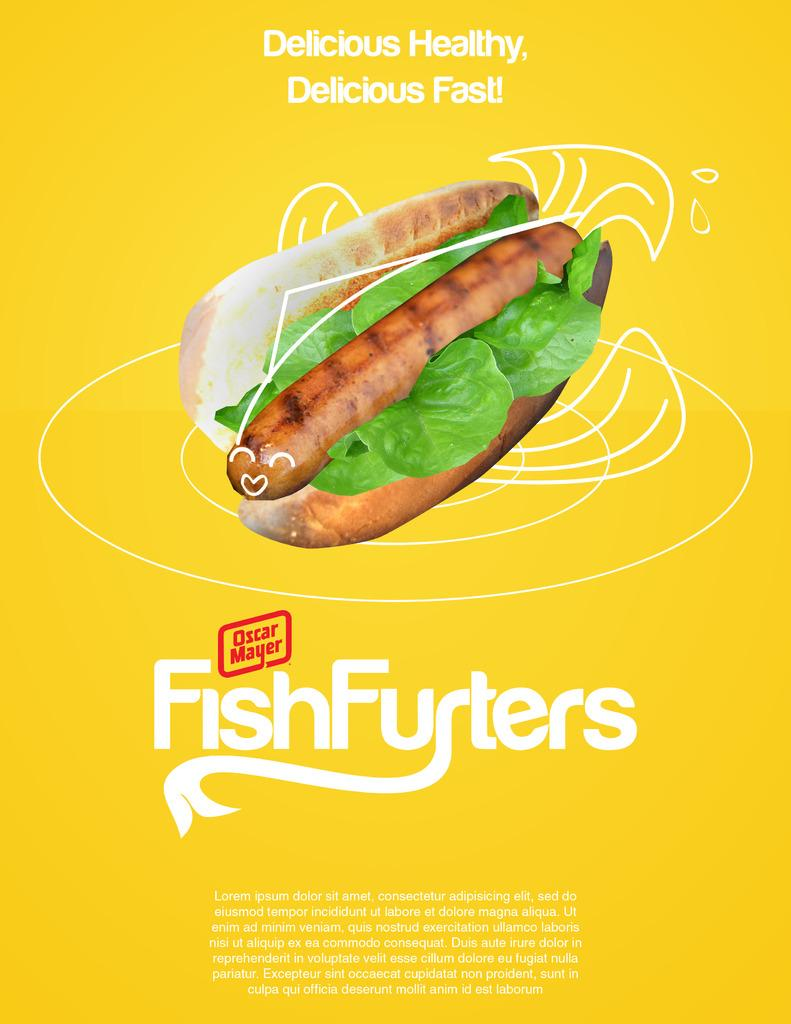What can be seen in the image related to consumption? There is food in the image. What else is present in the image besides the food? There is text in the image. What type of verse can be seen in the image? There is no verse present in the image; it only contains food and text. How does the cub contribute to the comfort in the image? There is no cub present in the image, so it cannot contribute to any comfort. 